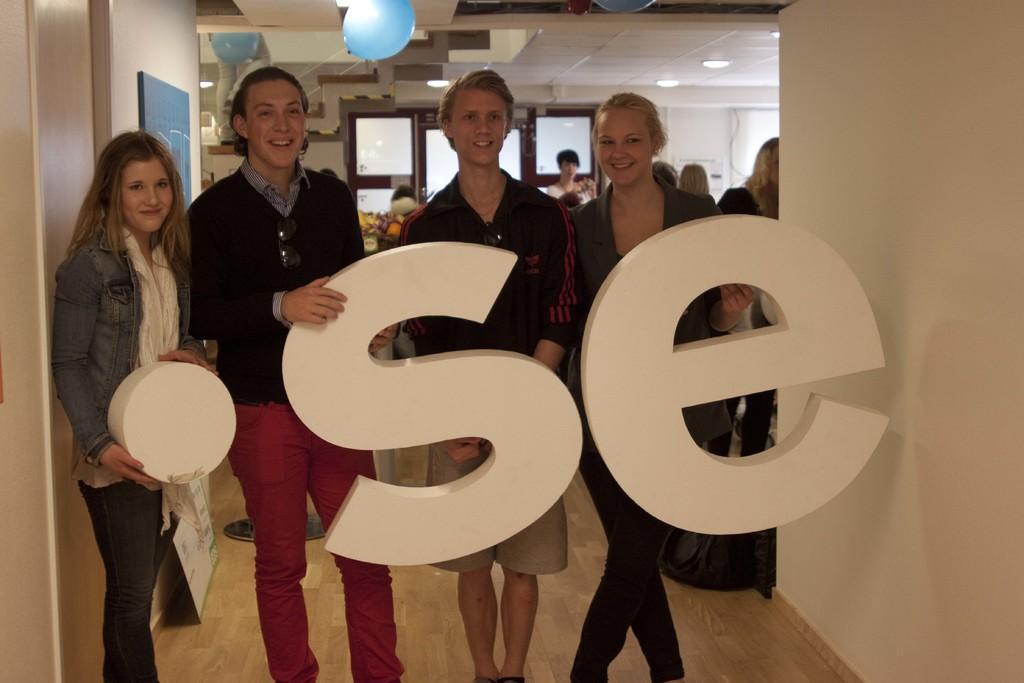Describe this image in one or two sentences. The picture is taken inside a hall. In the foreground there are four people they all are smiling. They are holding some structure. In the background there are many people. In the ceiling there are lights , balloons. In the background there is a window. 